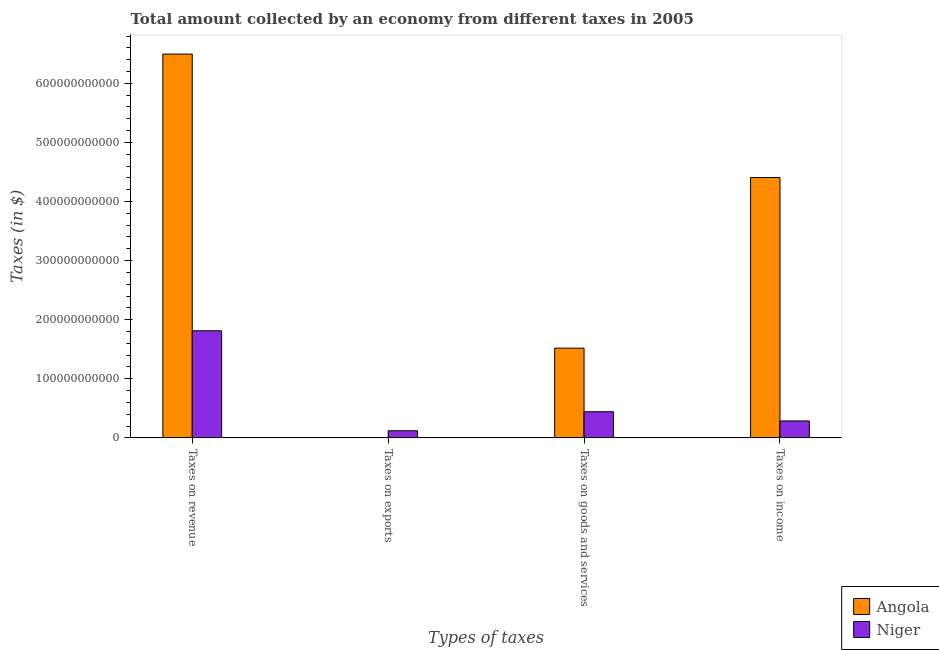How many different coloured bars are there?
Provide a short and direct response. 2. How many groups of bars are there?
Your answer should be compact. 4. Are the number of bars per tick equal to the number of legend labels?
Give a very brief answer. Yes. How many bars are there on the 2nd tick from the right?
Offer a very short reply. 2. What is the label of the 4th group of bars from the left?
Provide a succinct answer. Taxes on income. What is the amount collected as tax on goods in Niger?
Ensure brevity in your answer.  4.43e+1. Across all countries, what is the maximum amount collected as tax on revenue?
Ensure brevity in your answer.  6.49e+11. Across all countries, what is the minimum amount collected as tax on goods?
Offer a terse response. 4.43e+1. In which country was the amount collected as tax on revenue maximum?
Offer a terse response. Angola. In which country was the amount collected as tax on revenue minimum?
Your answer should be very brief. Niger. What is the total amount collected as tax on exports in the graph?
Your response must be concise. 1.22e+1. What is the difference between the amount collected as tax on exports in Angola and that in Niger?
Provide a succinct answer. -1.19e+1. What is the difference between the amount collected as tax on revenue in Niger and the amount collected as tax on exports in Angola?
Keep it short and to the point. 1.81e+11. What is the average amount collected as tax on goods per country?
Offer a very short reply. 9.80e+1. What is the difference between the amount collected as tax on revenue and amount collected as tax on income in Angola?
Ensure brevity in your answer.  2.09e+11. In how many countries, is the amount collected as tax on goods greater than 580000000000 $?
Offer a terse response. 0. What is the ratio of the amount collected as tax on income in Niger to that in Angola?
Provide a succinct answer. 0.07. Is the difference between the amount collected as tax on income in Angola and Niger greater than the difference between the amount collected as tax on revenue in Angola and Niger?
Offer a very short reply. No. What is the difference between the highest and the second highest amount collected as tax on goods?
Your answer should be very brief. 1.08e+11. What is the difference between the highest and the lowest amount collected as tax on exports?
Offer a terse response. 1.19e+1. In how many countries, is the amount collected as tax on revenue greater than the average amount collected as tax on revenue taken over all countries?
Give a very brief answer. 1. Is it the case that in every country, the sum of the amount collected as tax on exports and amount collected as tax on income is greater than the sum of amount collected as tax on goods and amount collected as tax on revenue?
Offer a very short reply. No. What does the 1st bar from the left in Taxes on revenue represents?
Provide a short and direct response. Angola. What does the 2nd bar from the right in Taxes on revenue represents?
Your answer should be very brief. Angola. How many countries are there in the graph?
Provide a short and direct response. 2. What is the difference between two consecutive major ticks on the Y-axis?
Make the answer very short. 1.00e+11. Are the values on the major ticks of Y-axis written in scientific E-notation?
Keep it short and to the point. No. Does the graph contain any zero values?
Provide a succinct answer. No. Does the graph contain grids?
Provide a succinct answer. No. What is the title of the graph?
Ensure brevity in your answer.  Total amount collected by an economy from different taxes in 2005. Does "Kenya" appear as one of the legend labels in the graph?
Your response must be concise. No. What is the label or title of the X-axis?
Your response must be concise. Types of taxes. What is the label or title of the Y-axis?
Offer a very short reply. Taxes (in $). What is the Taxes (in $) in Angola in Taxes on revenue?
Your response must be concise. 6.49e+11. What is the Taxes (in $) in Niger in Taxes on revenue?
Your response must be concise. 1.81e+11. What is the Taxes (in $) of Angola in Taxes on exports?
Offer a terse response. 1.44e+08. What is the Taxes (in $) in Niger in Taxes on exports?
Offer a very short reply. 1.20e+1. What is the Taxes (in $) in Angola in Taxes on goods and services?
Keep it short and to the point. 1.52e+11. What is the Taxes (in $) in Niger in Taxes on goods and services?
Offer a very short reply. 4.43e+1. What is the Taxes (in $) in Angola in Taxes on income?
Offer a very short reply. 4.41e+11. What is the Taxes (in $) of Niger in Taxes on income?
Provide a short and direct response. 2.86e+1. Across all Types of taxes, what is the maximum Taxes (in $) in Angola?
Keep it short and to the point. 6.49e+11. Across all Types of taxes, what is the maximum Taxes (in $) in Niger?
Your response must be concise. 1.81e+11. Across all Types of taxes, what is the minimum Taxes (in $) in Angola?
Your answer should be compact. 1.44e+08. Across all Types of taxes, what is the minimum Taxes (in $) in Niger?
Make the answer very short. 1.20e+1. What is the total Taxes (in $) of Angola in the graph?
Keep it short and to the point. 1.24e+12. What is the total Taxes (in $) of Niger in the graph?
Provide a succinct answer. 2.66e+11. What is the difference between the Taxes (in $) of Angola in Taxes on revenue and that in Taxes on exports?
Provide a short and direct response. 6.49e+11. What is the difference between the Taxes (in $) in Niger in Taxes on revenue and that in Taxes on exports?
Give a very brief answer. 1.69e+11. What is the difference between the Taxes (in $) of Angola in Taxes on revenue and that in Taxes on goods and services?
Your answer should be very brief. 4.98e+11. What is the difference between the Taxes (in $) of Niger in Taxes on revenue and that in Taxes on goods and services?
Keep it short and to the point. 1.37e+11. What is the difference between the Taxes (in $) in Angola in Taxes on revenue and that in Taxes on income?
Make the answer very short. 2.09e+11. What is the difference between the Taxes (in $) of Niger in Taxes on revenue and that in Taxes on income?
Ensure brevity in your answer.  1.53e+11. What is the difference between the Taxes (in $) in Angola in Taxes on exports and that in Taxes on goods and services?
Your answer should be very brief. -1.52e+11. What is the difference between the Taxes (in $) of Niger in Taxes on exports and that in Taxes on goods and services?
Your answer should be compact. -3.22e+1. What is the difference between the Taxes (in $) in Angola in Taxes on exports and that in Taxes on income?
Offer a very short reply. -4.40e+11. What is the difference between the Taxes (in $) in Niger in Taxes on exports and that in Taxes on income?
Provide a short and direct response. -1.66e+1. What is the difference between the Taxes (in $) of Angola in Taxes on goods and services and that in Taxes on income?
Give a very brief answer. -2.89e+11. What is the difference between the Taxes (in $) of Niger in Taxes on goods and services and that in Taxes on income?
Provide a succinct answer. 1.56e+1. What is the difference between the Taxes (in $) of Angola in Taxes on revenue and the Taxes (in $) of Niger in Taxes on exports?
Your answer should be very brief. 6.37e+11. What is the difference between the Taxes (in $) in Angola in Taxes on revenue and the Taxes (in $) in Niger in Taxes on goods and services?
Provide a succinct answer. 6.05e+11. What is the difference between the Taxes (in $) of Angola in Taxes on revenue and the Taxes (in $) of Niger in Taxes on income?
Offer a very short reply. 6.21e+11. What is the difference between the Taxes (in $) of Angola in Taxes on exports and the Taxes (in $) of Niger in Taxes on goods and services?
Give a very brief answer. -4.41e+1. What is the difference between the Taxes (in $) of Angola in Taxes on exports and the Taxes (in $) of Niger in Taxes on income?
Your response must be concise. -2.85e+1. What is the difference between the Taxes (in $) of Angola in Taxes on goods and services and the Taxes (in $) of Niger in Taxes on income?
Offer a very short reply. 1.23e+11. What is the average Taxes (in $) of Angola per Types of taxes?
Offer a terse response. 3.11e+11. What is the average Taxes (in $) of Niger per Types of taxes?
Keep it short and to the point. 6.65e+1. What is the difference between the Taxes (in $) in Angola and Taxes (in $) in Niger in Taxes on revenue?
Keep it short and to the point. 4.68e+11. What is the difference between the Taxes (in $) of Angola and Taxes (in $) of Niger in Taxes on exports?
Make the answer very short. -1.19e+1. What is the difference between the Taxes (in $) in Angola and Taxes (in $) in Niger in Taxes on goods and services?
Offer a terse response. 1.08e+11. What is the difference between the Taxes (in $) in Angola and Taxes (in $) in Niger in Taxes on income?
Your response must be concise. 4.12e+11. What is the ratio of the Taxes (in $) in Angola in Taxes on revenue to that in Taxes on exports?
Your answer should be very brief. 4506.23. What is the ratio of the Taxes (in $) of Niger in Taxes on revenue to that in Taxes on exports?
Make the answer very short. 15.09. What is the ratio of the Taxes (in $) of Angola in Taxes on revenue to that in Taxes on goods and services?
Provide a succinct answer. 4.28. What is the ratio of the Taxes (in $) of Niger in Taxes on revenue to that in Taxes on goods and services?
Make the answer very short. 4.1. What is the ratio of the Taxes (in $) in Angola in Taxes on revenue to that in Taxes on income?
Keep it short and to the point. 1.47. What is the ratio of the Taxes (in $) in Niger in Taxes on revenue to that in Taxes on income?
Provide a succinct answer. 6.33. What is the ratio of the Taxes (in $) in Angola in Taxes on exports to that in Taxes on goods and services?
Give a very brief answer. 0. What is the ratio of the Taxes (in $) of Niger in Taxes on exports to that in Taxes on goods and services?
Offer a very short reply. 0.27. What is the ratio of the Taxes (in $) in Niger in Taxes on exports to that in Taxes on income?
Make the answer very short. 0.42. What is the ratio of the Taxes (in $) of Angola in Taxes on goods and services to that in Taxes on income?
Your response must be concise. 0.34. What is the ratio of the Taxes (in $) of Niger in Taxes on goods and services to that in Taxes on income?
Your response must be concise. 1.54. What is the difference between the highest and the second highest Taxes (in $) in Angola?
Provide a short and direct response. 2.09e+11. What is the difference between the highest and the second highest Taxes (in $) in Niger?
Your answer should be compact. 1.37e+11. What is the difference between the highest and the lowest Taxes (in $) of Angola?
Your answer should be compact. 6.49e+11. What is the difference between the highest and the lowest Taxes (in $) in Niger?
Provide a short and direct response. 1.69e+11. 